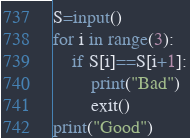<code> <loc_0><loc_0><loc_500><loc_500><_Python_>S=input()
for i in range(3):
    if S[i]==S[i+1]:
        print("Bad")
        exit()
print("Good")</code> 